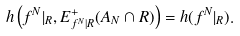<formula> <loc_0><loc_0><loc_500><loc_500>h \left ( f ^ { N } | _ { R } , E ^ { + } _ { f ^ { N } | R } ( A _ { N } \cap R ) \right ) = h ( f ^ { N } | _ { R } ) .</formula> 